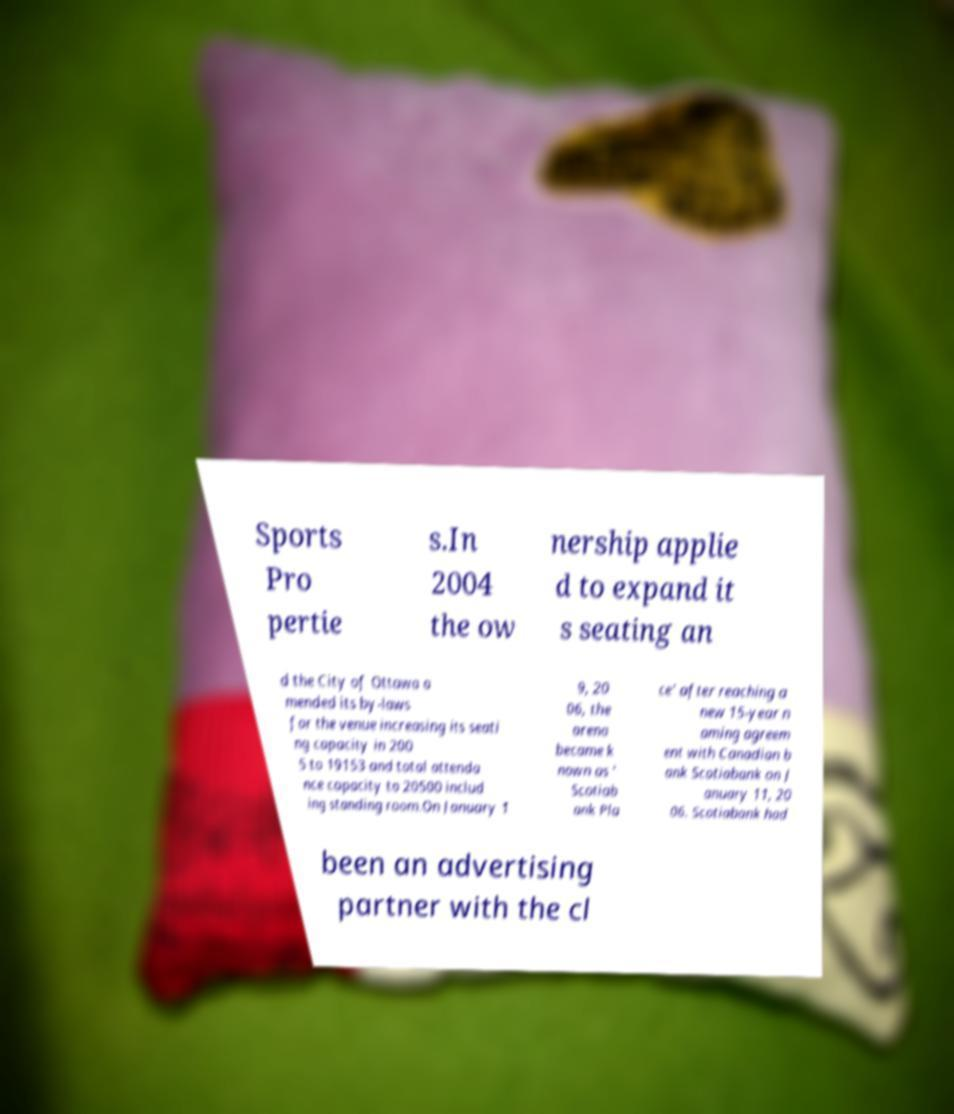Please read and relay the text visible in this image. What does it say? Sports Pro pertie s.In 2004 the ow nership applie d to expand it s seating an d the City of Ottawa a mended its by-laws for the venue increasing its seati ng capacity in 200 5 to 19153 and total attenda nce capacity to 20500 includ ing standing room.On January 1 9, 20 06, the arena became k nown as ' Scotiab ank Pla ce' after reaching a new 15-year n aming agreem ent with Canadian b ank Scotiabank on J anuary 11, 20 06. Scotiabank had been an advertising partner with the cl 